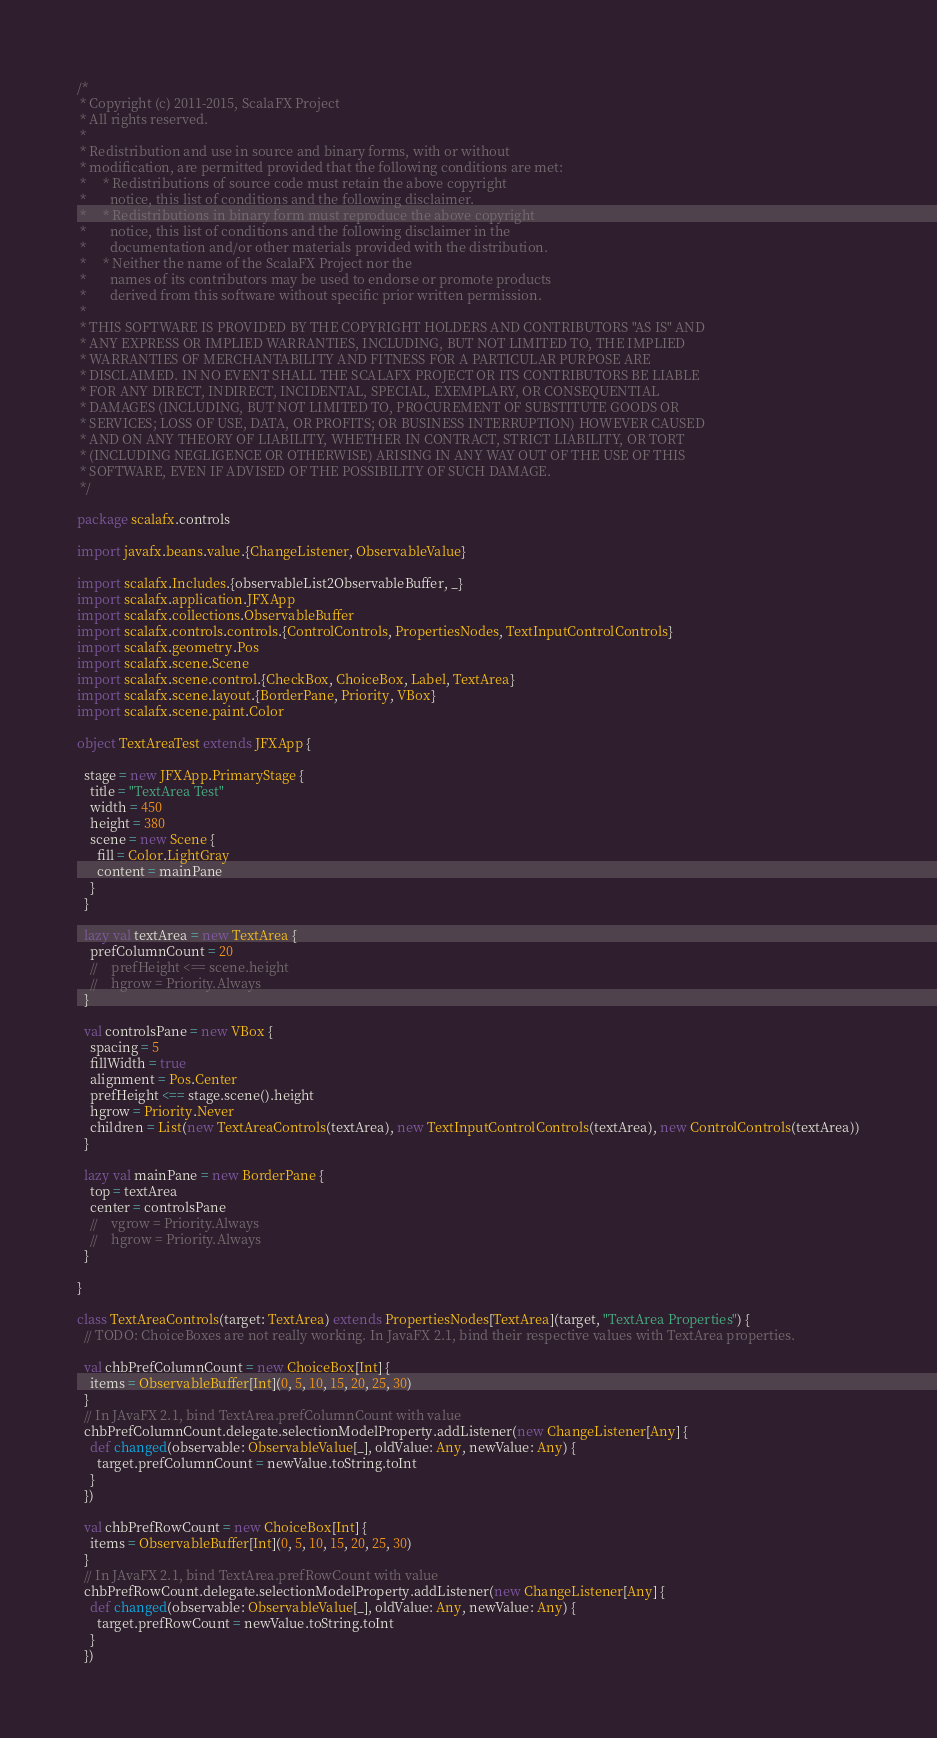<code> <loc_0><loc_0><loc_500><loc_500><_Scala_>/*
 * Copyright (c) 2011-2015, ScalaFX Project
 * All rights reserved.
 *
 * Redistribution and use in source and binary forms, with or without
 * modification, are permitted provided that the following conditions are met:
 *     * Redistributions of source code must retain the above copyright
 *       notice, this list of conditions and the following disclaimer.
 *     * Redistributions in binary form must reproduce the above copyright
 *       notice, this list of conditions and the following disclaimer in the
 *       documentation and/or other materials provided with the distribution.
 *     * Neither the name of the ScalaFX Project nor the
 *       names of its contributors may be used to endorse or promote products
 *       derived from this software without specific prior written permission.
 *
 * THIS SOFTWARE IS PROVIDED BY THE COPYRIGHT HOLDERS AND CONTRIBUTORS "AS IS" AND
 * ANY EXPRESS OR IMPLIED WARRANTIES, INCLUDING, BUT NOT LIMITED TO, THE IMPLIED
 * WARRANTIES OF MERCHANTABILITY AND FITNESS FOR A PARTICULAR PURPOSE ARE
 * DISCLAIMED. IN NO EVENT SHALL THE SCALAFX PROJECT OR ITS CONTRIBUTORS BE LIABLE
 * FOR ANY DIRECT, INDIRECT, INCIDENTAL, SPECIAL, EXEMPLARY, OR CONSEQUENTIAL
 * DAMAGES (INCLUDING, BUT NOT LIMITED TO, PROCUREMENT OF SUBSTITUTE GOODS OR
 * SERVICES; LOSS OF USE, DATA, OR PROFITS; OR BUSINESS INTERRUPTION) HOWEVER CAUSED
 * AND ON ANY THEORY OF LIABILITY, WHETHER IN CONTRACT, STRICT LIABILITY, OR TORT
 * (INCLUDING NEGLIGENCE OR OTHERWISE) ARISING IN ANY WAY OUT OF THE USE OF THIS
 * SOFTWARE, EVEN IF ADVISED OF THE POSSIBILITY OF SUCH DAMAGE.
 */

package scalafx.controls

import javafx.beans.value.{ChangeListener, ObservableValue}

import scalafx.Includes.{observableList2ObservableBuffer, _}
import scalafx.application.JFXApp
import scalafx.collections.ObservableBuffer
import scalafx.controls.controls.{ControlControls, PropertiesNodes, TextInputControlControls}
import scalafx.geometry.Pos
import scalafx.scene.Scene
import scalafx.scene.control.{CheckBox, ChoiceBox, Label, TextArea}
import scalafx.scene.layout.{BorderPane, Priority, VBox}
import scalafx.scene.paint.Color

object TextAreaTest extends JFXApp {

  stage = new JFXApp.PrimaryStage {
    title = "TextArea Test"
    width = 450
    height = 380
    scene = new Scene {
      fill = Color.LightGray
      content = mainPane
    }
  }

  lazy val textArea = new TextArea {
    prefColumnCount = 20
    //    prefHeight <== scene.height
    //    hgrow = Priority.Always
  }

  val controlsPane = new VBox {
    spacing = 5
    fillWidth = true
    alignment = Pos.Center
    prefHeight <== stage.scene().height
    hgrow = Priority.Never
    children = List(new TextAreaControls(textArea), new TextInputControlControls(textArea), new ControlControls(textArea))
  }

  lazy val mainPane = new BorderPane {
    top = textArea
    center = controlsPane
    //    vgrow = Priority.Always
    //    hgrow = Priority.Always
  }

}

class TextAreaControls(target: TextArea) extends PropertiesNodes[TextArea](target, "TextArea Properties") {
  // TODO: ChoiceBoxes are not really working. In JavaFX 2.1, bind their respective values with TextArea properties.

  val chbPrefColumnCount = new ChoiceBox[Int] {
    items = ObservableBuffer[Int](0, 5, 10, 15, 20, 25, 30)
  }
  // In JAvaFX 2.1, bind TextArea.prefColumnCount with value
  chbPrefColumnCount.delegate.selectionModelProperty.addListener(new ChangeListener[Any] {
    def changed(observable: ObservableValue[_], oldValue: Any, newValue: Any) {
      target.prefColumnCount = newValue.toString.toInt
    }
  })

  val chbPrefRowCount = new ChoiceBox[Int] {
    items = ObservableBuffer[Int](0, 5, 10, 15, 20, 25, 30)
  }
  // In JAvaFX 2.1, bind TextArea.prefRowCount with value
  chbPrefRowCount.delegate.selectionModelProperty.addListener(new ChangeListener[Any] {
    def changed(observable: ObservableValue[_], oldValue: Any, newValue: Any) {
      target.prefRowCount = newValue.toString.toInt
    }
  })
</code> 